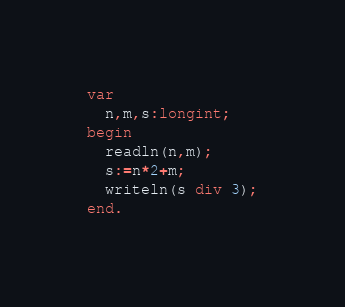Convert code to text. <code><loc_0><loc_0><loc_500><loc_500><_Pascal_>var
  n,m,s:longint;
begin
  readln(n,m);
  s:=n*2+m;
  writeln(s div 3);
end.</code> 